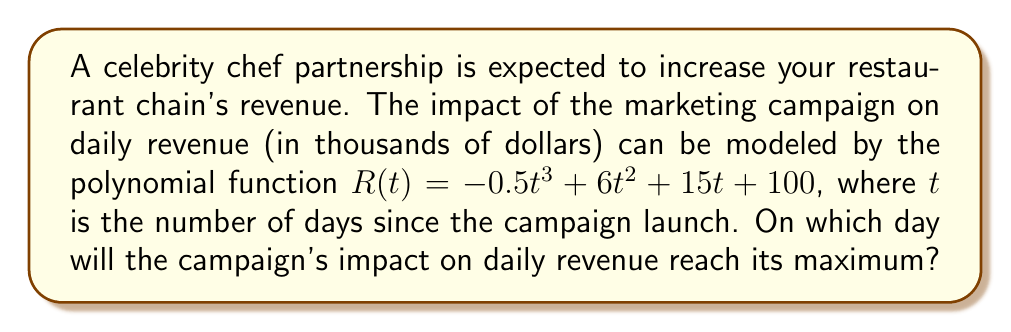What is the answer to this math problem? To find the day when the campaign's impact on daily revenue reaches its maximum, we need to follow these steps:

1) The maximum point of the revenue function occurs where its derivative equals zero. Let's find the derivative of $R(t)$:

   $R'(t) = -1.5t^2 + 12t + 15$

2) Set the derivative equal to zero and solve for $t$:

   $-1.5t^2 + 12t + 15 = 0$

3) This is a quadratic equation. We can solve it using the quadratic formula:
   $t = \frac{-b \pm \sqrt{b^2 - 4ac}}{2a}$

   Where $a = -1.5$, $b = 12$, and $c = 15$

4) Substituting these values:

   $t = \frac{-12 \pm \sqrt{12^2 - 4(-1.5)(15)}}{2(-1.5)}$

5) Simplifying:

   $t = \frac{-12 \pm \sqrt{144 + 90}}{-3} = \frac{-12 \pm \sqrt{234}}{-3}$

6) This gives us two solutions:

   $t_1 = \frac{-12 + \sqrt{234}}{-3} \approx 6.41$
   $t_2 = \frac{-12 - \sqrt{234}}{-3} \approx -1.74$

7) Since time cannot be negative in this context, we discard the negative solution.

8) The positive solution is approximately 6.41 days. Since we're dealing with whole days, we round this to the nearest integer: 6 days.
Answer: 6 days 